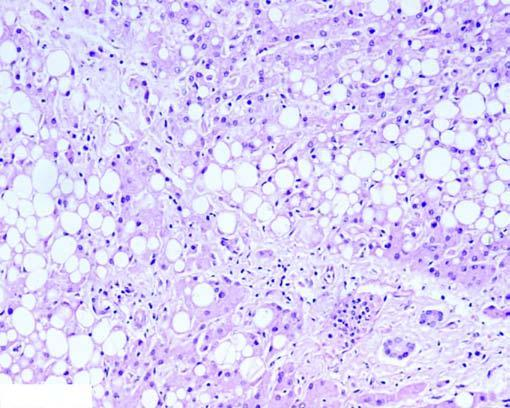what are many of the hepatocytes distended with pushing the nuclei to the periphery (macrovesicles), while others show multiple small vacuoles in the cytoplasm (microvesicles)?
Answer the question using a single word or phrase. Large fat 